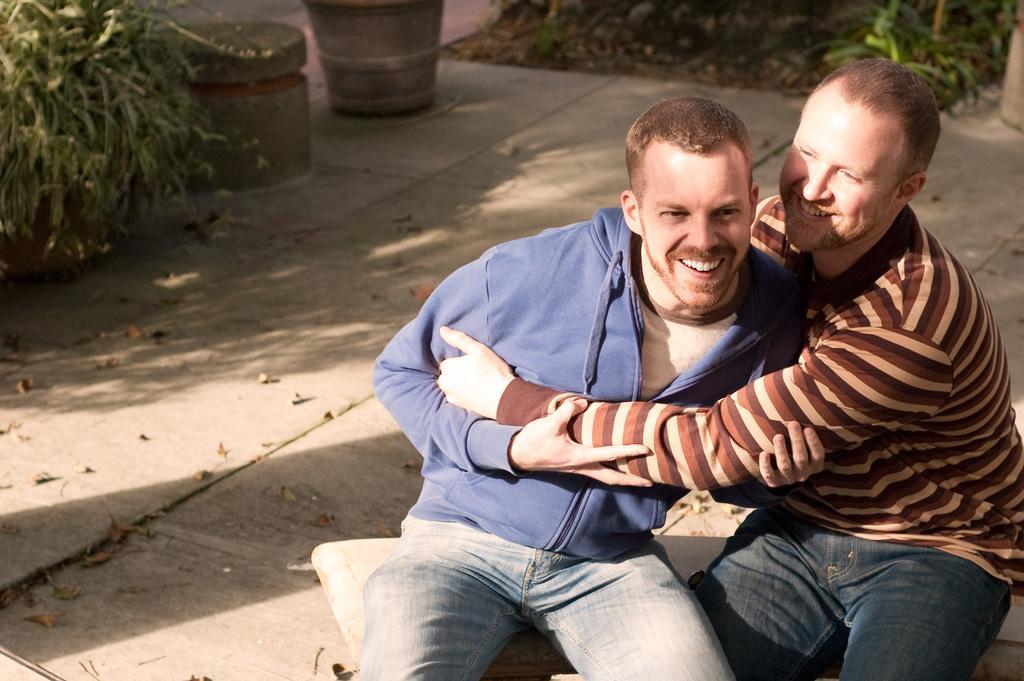Describe this image in one or two sentences. In this picture we can see two men are sitting and smiling in the front, on the left side and right side there are plants, we can see some leaves at the bottom. 